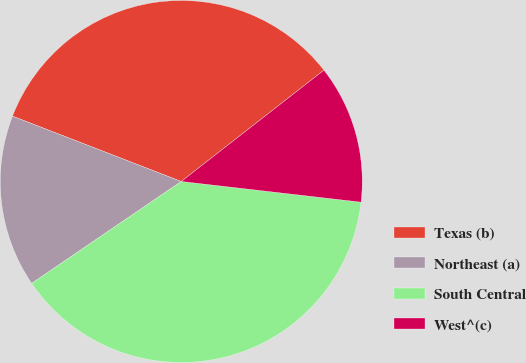Convert chart. <chart><loc_0><loc_0><loc_500><loc_500><pie_chart><fcel>Texas (b)<fcel>Northeast (a)<fcel>South Central<fcel>West^(c)<nl><fcel>33.58%<fcel>15.4%<fcel>38.66%<fcel>12.37%<nl></chart> 